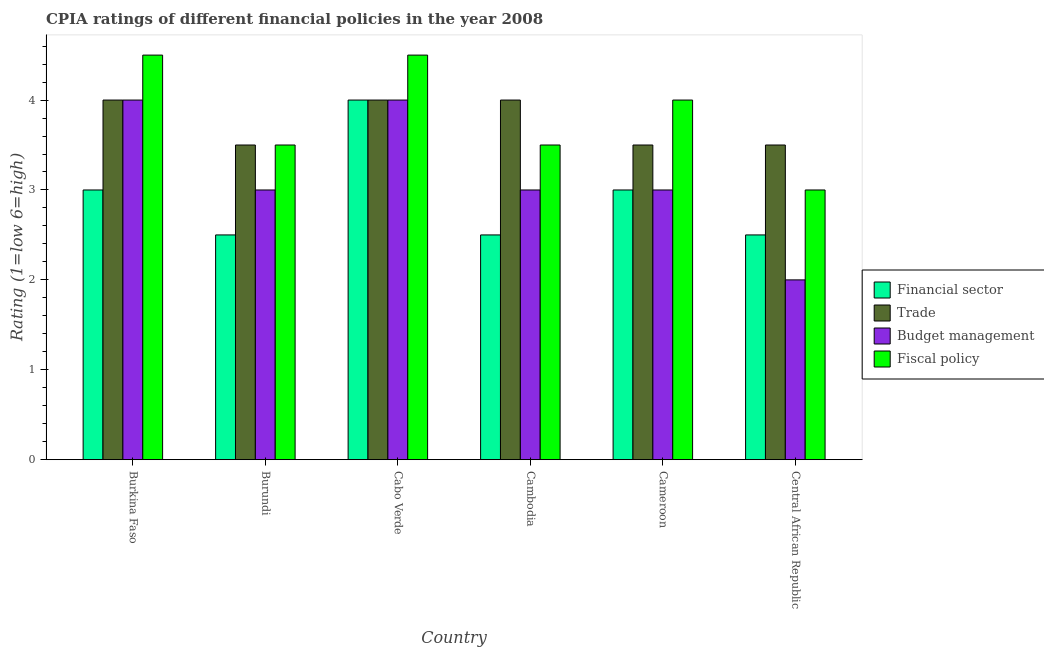How many groups of bars are there?
Provide a succinct answer. 6. Are the number of bars per tick equal to the number of legend labels?
Your response must be concise. Yes. Are the number of bars on each tick of the X-axis equal?
Your response must be concise. Yes. How many bars are there on the 5th tick from the left?
Your answer should be very brief. 4. What is the label of the 4th group of bars from the left?
Keep it short and to the point. Cambodia. What is the cpia rating of fiscal policy in Cambodia?
Your response must be concise. 3.5. Across all countries, what is the maximum cpia rating of fiscal policy?
Offer a very short reply. 4.5. In which country was the cpia rating of fiscal policy maximum?
Provide a short and direct response. Burkina Faso. In which country was the cpia rating of financial sector minimum?
Ensure brevity in your answer.  Burundi. What is the average cpia rating of financial sector per country?
Make the answer very short. 2.92. What is the difference between the cpia rating of financial sector and cpia rating of budget management in Cameroon?
Offer a terse response. 0. What is the ratio of the cpia rating of budget management in Burundi to that in Cameroon?
Make the answer very short. 1. What is the difference between the highest and the second highest cpia rating of financial sector?
Give a very brief answer. 1. What is the difference between the highest and the lowest cpia rating of trade?
Your answer should be compact. 0.5. In how many countries, is the cpia rating of financial sector greater than the average cpia rating of financial sector taken over all countries?
Offer a terse response. 3. Is it the case that in every country, the sum of the cpia rating of trade and cpia rating of budget management is greater than the sum of cpia rating of financial sector and cpia rating of fiscal policy?
Your response must be concise. No. What does the 3rd bar from the left in Central African Republic represents?
Provide a short and direct response. Budget management. What does the 1st bar from the right in Cambodia represents?
Your response must be concise. Fiscal policy. Is it the case that in every country, the sum of the cpia rating of financial sector and cpia rating of trade is greater than the cpia rating of budget management?
Your answer should be compact. Yes. How many bars are there?
Offer a terse response. 24. Are all the bars in the graph horizontal?
Give a very brief answer. No. Are the values on the major ticks of Y-axis written in scientific E-notation?
Offer a terse response. No. Where does the legend appear in the graph?
Give a very brief answer. Center right. How are the legend labels stacked?
Offer a very short reply. Vertical. What is the title of the graph?
Provide a succinct answer. CPIA ratings of different financial policies in the year 2008. Does "Industry" appear as one of the legend labels in the graph?
Give a very brief answer. No. What is the label or title of the X-axis?
Your answer should be very brief. Country. What is the label or title of the Y-axis?
Keep it short and to the point. Rating (1=low 6=high). What is the Rating (1=low 6=high) in Trade in Burkina Faso?
Your response must be concise. 4. What is the Rating (1=low 6=high) of Trade in Burundi?
Provide a short and direct response. 3.5. What is the Rating (1=low 6=high) in Fiscal policy in Burundi?
Keep it short and to the point. 3.5. What is the Rating (1=low 6=high) of Budget management in Cabo Verde?
Provide a succinct answer. 4. What is the Rating (1=low 6=high) in Budget management in Cambodia?
Offer a very short reply. 3. What is the Rating (1=low 6=high) of Financial sector in Cameroon?
Your answer should be compact. 3. What is the Rating (1=low 6=high) in Trade in Cameroon?
Your response must be concise. 3.5. What is the Rating (1=low 6=high) in Budget management in Cameroon?
Offer a terse response. 3. What is the Rating (1=low 6=high) of Fiscal policy in Cameroon?
Your response must be concise. 4. What is the Rating (1=low 6=high) in Fiscal policy in Central African Republic?
Ensure brevity in your answer.  3. Across all countries, what is the maximum Rating (1=low 6=high) of Trade?
Make the answer very short. 4. Across all countries, what is the maximum Rating (1=low 6=high) in Budget management?
Keep it short and to the point. 4. Across all countries, what is the maximum Rating (1=low 6=high) in Fiscal policy?
Keep it short and to the point. 4.5. Across all countries, what is the minimum Rating (1=low 6=high) in Financial sector?
Your answer should be very brief. 2.5. Across all countries, what is the minimum Rating (1=low 6=high) of Fiscal policy?
Offer a terse response. 3. What is the total Rating (1=low 6=high) in Financial sector in the graph?
Make the answer very short. 17.5. What is the total Rating (1=low 6=high) of Trade in the graph?
Your response must be concise. 22.5. What is the total Rating (1=low 6=high) of Budget management in the graph?
Make the answer very short. 19. What is the difference between the Rating (1=low 6=high) of Financial sector in Burkina Faso and that in Burundi?
Provide a short and direct response. 0.5. What is the difference between the Rating (1=low 6=high) in Budget management in Burkina Faso and that in Burundi?
Make the answer very short. 1. What is the difference between the Rating (1=low 6=high) in Financial sector in Burkina Faso and that in Cabo Verde?
Offer a very short reply. -1. What is the difference between the Rating (1=low 6=high) of Budget management in Burkina Faso and that in Cabo Verde?
Provide a succinct answer. 0. What is the difference between the Rating (1=low 6=high) in Financial sector in Burkina Faso and that in Cambodia?
Keep it short and to the point. 0.5. What is the difference between the Rating (1=low 6=high) of Trade in Burkina Faso and that in Cambodia?
Make the answer very short. 0. What is the difference between the Rating (1=low 6=high) of Budget management in Burkina Faso and that in Cambodia?
Your answer should be very brief. 1. What is the difference between the Rating (1=low 6=high) in Financial sector in Burkina Faso and that in Cameroon?
Provide a succinct answer. 0. What is the difference between the Rating (1=low 6=high) of Trade in Burkina Faso and that in Cameroon?
Make the answer very short. 0.5. What is the difference between the Rating (1=low 6=high) of Financial sector in Burundi and that in Cabo Verde?
Provide a short and direct response. -1.5. What is the difference between the Rating (1=low 6=high) of Trade in Burundi and that in Cabo Verde?
Give a very brief answer. -0.5. What is the difference between the Rating (1=low 6=high) in Budget management in Burundi and that in Cambodia?
Your answer should be compact. 0. What is the difference between the Rating (1=low 6=high) of Trade in Burundi and that in Cameroon?
Offer a terse response. 0. What is the difference between the Rating (1=low 6=high) in Budget management in Burundi and that in Cameroon?
Your response must be concise. 0. What is the difference between the Rating (1=low 6=high) of Fiscal policy in Burundi and that in Cameroon?
Offer a very short reply. -0.5. What is the difference between the Rating (1=low 6=high) of Budget management in Burundi and that in Central African Republic?
Offer a very short reply. 1. What is the difference between the Rating (1=low 6=high) in Trade in Cabo Verde and that in Cameroon?
Your response must be concise. 0.5. What is the difference between the Rating (1=low 6=high) in Fiscal policy in Cabo Verde and that in Cameroon?
Your response must be concise. 0.5. What is the difference between the Rating (1=low 6=high) of Trade in Cambodia and that in Cameroon?
Your answer should be very brief. 0.5. What is the difference between the Rating (1=low 6=high) in Budget management in Cambodia and that in Cameroon?
Your answer should be compact. 0. What is the difference between the Rating (1=low 6=high) of Fiscal policy in Cambodia and that in Cameroon?
Give a very brief answer. -0.5. What is the difference between the Rating (1=low 6=high) of Financial sector in Cambodia and that in Central African Republic?
Give a very brief answer. 0. What is the difference between the Rating (1=low 6=high) of Trade in Cambodia and that in Central African Republic?
Provide a succinct answer. 0.5. What is the difference between the Rating (1=low 6=high) in Financial sector in Burkina Faso and the Rating (1=low 6=high) in Budget management in Cabo Verde?
Your answer should be very brief. -1. What is the difference between the Rating (1=low 6=high) in Financial sector in Burkina Faso and the Rating (1=low 6=high) in Fiscal policy in Cabo Verde?
Your answer should be compact. -1.5. What is the difference between the Rating (1=low 6=high) in Budget management in Burkina Faso and the Rating (1=low 6=high) in Fiscal policy in Cabo Verde?
Your answer should be compact. -0.5. What is the difference between the Rating (1=low 6=high) in Financial sector in Burkina Faso and the Rating (1=low 6=high) in Trade in Cambodia?
Make the answer very short. -1. What is the difference between the Rating (1=low 6=high) of Financial sector in Burkina Faso and the Rating (1=low 6=high) of Budget management in Cambodia?
Your answer should be compact. 0. What is the difference between the Rating (1=low 6=high) in Budget management in Burkina Faso and the Rating (1=low 6=high) in Fiscal policy in Cambodia?
Ensure brevity in your answer.  0.5. What is the difference between the Rating (1=low 6=high) of Financial sector in Burkina Faso and the Rating (1=low 6=high) of Trade in Cameroon?
Give a very brief answer. -0.5. What is the difference between the Rating (1=low 6=high) in Financial sector in Burkina Faso and the Rating (1=low 6=high) in Fiscal policy in Cameroon?
Offer a terse response. -1. What is the difference between the Rating (1=low 6=high) in Trade in Burkina Faso and the Rating (1=low 6=high) in Budget management in Cameroon?
Your answer should be very brief. 1. What is the difference between the Rating (1=low 6=high) of Financial sector in Burkina Faso and the Rating (1=low 6=high) of Trade in Central African Republic?
Make the answer very short. -0.5. What is the difference between the Rating (1=low 6=high) in Financial sector in Burkina Faso and the Rating (1=low 6=high) in Budget management in Central African Republic?
Offer a very short reply. 1. What is the difference between the Rating (1=low 6=high) of Trade in Burkina Faso and the Rating (1=low 6=high) of Budget management in Central African Republic?
Keep it short and to the point. 2. What is the difference between the Rating (1=low 6=high) in Financial sector in Burundi and the Rating (1=low 6=high) in Budget management in Cabo Verde?
Ensure brevity in your answer.  -1.5. What is the difference between the Rating (1=low 6=high) in Financial sector in Burundi and the Rating (1=low 6=high) in Fiscal policy in Cabo Verde?
Offer a very short reply. -2. What is the difference between the Rating (1=low 6=high) of Budget management in Burundi and the Rating (1=low 6=high) of Fiscal policy in Cabo Verde?
Make the answer very short. -1.5. What is the difference between the Rating (1=low 6=high) of Financial sector in Burundi and the Rating (1=low 6=high) of Trade in Cambodia?
Your response must be concise. -1.5. What is the difference between the Rating (1=low 6=high) in Financial sector in Burundi and the Rating (1=low 6=high) in Fiscal policy in Cambodia?
Your response must be concise. -1. What is the difference between the Rating (1=low 6=high) of Budget management in Burundi and the Rating (1=low 6=high) of Fiscal policy in Cambodia?
Your answer should be compact. -0.5. What is the difference between the Rating (1=low 6=high) in Financial sector in Burundi and the Rating (1=low 6=high) in Trade in Cameroon?
Make the answer very short. -1. What is the difference between the Rating (1=low 6=high) in Financial sector in Burundi and the Rating (1=low 6=high) in Fiscal policy in Cameroon?
Ensure brevity in your answer.  -1.5. What is the difference between the Rating (1=low 6=high) in Trade in Burundi and the Rating (1=low 6=high) in Budget management in Cameroon?
Offer a very short reply. 0.5. What is the difference between the Rating (1=low 6=high) in Financial sector in Burundi and the Rating (1=low 6=high) in Budget management in Central African Republic?
Give a very brief answer. 0.5. What is the difference between the Rating (1=low 6=high) in Financial sector in Burundi and the Rating (1=low 6=high) in Fiscal policy in Central African Republic?
Give a very brief answer. -0.5. What is the difference between the Rating (1=low 6=high) of Trade in Burundi and the Rating (1=low 6=high) of Budget management in Central African Republic?
Offer a very short reply. 1.5. What is the difference between the Rating (1=low 6=high) in Budget management in Burundi and the Rating (1=low 6=high) in Fiscal policy in Central African Republic?
Your response must be concise. 0. What is the difference between the Rating (1=low 6=high) of Financial sector in Cabo Verde and the Rating (1=low 6=high) of Trade in Cambodia?
Ensure brevity in your answer.  0. What is the difference between the Rating (1=low 6=high) in Trade in Cabo Verde and the Rating (1=low 6=high) in Fiscal policy in Cambodia?
Your answer should be very brief. 0.5. What is the difference between the Rating (1=low 6=high) of Budget management in Cabo Verde and the Rating (1=low 6=high) of Fiscal policy in Cambodia?
Your response must be concise. 0.5. What is the difference between the Rating (1=low 6=high) in Financial sector in Cabo Verde and the Rating (1=low 6=high) in Fiscal policy in Cameroon?
Provide a succinct answer. 0. What is the difference between the Rating (1=low 6=high) of Budget management in Cabo Verde and the Rating (1=low 6=high) of Fiscal policy in Cameroon?
Offer a terse response. 0. What is the difference between the Rating (1=low 6=high) in Financial sector in Cabo Verde and the Rating (1=low 6=high) in Trade in Central African Republic?
Make the answer very short. 0.5. What is the difference between the Rating (1=low 6=high) of Budget management in Cabo Verde and the Rating (1=low 6=high) of Fiscal policy in Central African Republic?
Offer a very short reply. 1. What is the difference between the Rating (1=low 6=high) of Financial sector in Cambodia and the Rating (1=low 6=high) of Budget management in Cameroon?
Offer a very short reply. -0.5. What is the difference between the Rating (1=low 6=high) in Financial sector in Cambodia and the Rating (1=low 6=high) in Fiscal policy in Cameroon?
Offer a very short reply. -1.5. What is the difference between the Rating (1=low 6=high) of Trade in Cambodia and the Rating (1=low 6=high) of Fiscal policy in Cameroon?
Give a very brief answer. 0. What is the difference between the Rating (1=low 6=high) in Financial sector in Cambodia and the Rating (1=low 6=high) in Budget management in Central African Republic?
Provide a short and direct response. 0.5. What is the difference between the Rating (1=low 6=high) in Financial sector in Cambodia and the Rating (1=low 6=high) in Fiscal policy in Central African Republic?
Offer a very short reply. -0.5. What is the difference between the Rating (1=low 6=high) of Trade in Cambodia and the Rating (1=low 6=high) of Budget management in Central African Republic?
Keep it short and to the point. 2. What is the difference between the Rating (1=low 6=high) of Budget management in Cambodia and the Rating (1=low 6=high) of Fiscal policy in Central African Republic?
Your answer should be very brief. 0. What is the difference between the Rating (1=low 6=high) of Financial sector in Cameroon and the Rating (1=low 6=high) of Trade in Central African Republic?
Provide a succinct answer. -0.5. What is the difference between the Rating (1=low 6=high) of Financial sector in Cameroon and the Rating (1=low 6=high) of Budget management in Central African Republic?
Make the answer very short. 1. What is the difference between the Rating (1=low 6=high) in Trade in Cameroon and the Rating (1=low 6=high) in Fiscal policy in Central African Republic?
Provide a succinct answer. 0.5. What is the difference between the Rating (1=low 6=high) of Budget management in Cameroon and the Rating (1=low 6=high) of Fiscal policy in Central African Republic?
Keep it short and to the point. 0. What is the average Rating (1=low 6=high) of Financial sector per country?
Your answer should be compact. 2.92. What is the average Rating (1=low 6=high) of Trade per country?
Keep it short and to the point. 3.75. What is the average Rating (1=low 6=high) of Budget management per country?
Keep it short and to the point. 3.17. What is the average Rating (1=low 6=high) in Fiscal policy per country?
Provide a short and direct response. 3.83. What is the difference between the Rating (1=low 6=high) of Financial sector and Rating (1=low 6=high) of Trade in Burkina Faso?
Offer a very short reply. -1. What is the difference between the Rating (1=low 6=high) in Financial sector and Rating (1=low 6=high) in Budget management in Burkina Faso?
Give a very brief answer. -1. What is the difference between the Rating (1=low 6=high) in Financial sector and Rating (1=low 6=high) in Fiscal policy in Burkina Faso?
Provide a succinct answer. -1.5. What is the difference between the Rating (1=low 6=high) of Trade and Rating (1=low 6=high) of Fiscal policy in Burkina Faso?
Your answer should be compact. -0.5. What is the difference between the Rating (1=low 6=high) in Trade and Rating (1=low 6=high) in Budget management in Burundi?
Keep it short and to the point. 0.5. What is the difference between the Rating (1=low 6=high) of Financial sector and Rating (1=low 6=high) of Trade in Cabo Verde?
Your answer should be very brief. 0. What is the difference between the Rating (1=low 6=high) of Financial sector and Rating (1=low 6=high) of Budget management in Cabo Verde?
Your response must be concise. 0. What is the difference between the Rating (1=low 6=high) in Budget management and Rating (1=low 6=high) in Fiscal policy in Cabo Verde?
Offer a very short reply. -0.5. What is the difference between the Rating (1=low 6=high) of Financial sector and Rating (1=low 6=high) of Fiscal policy in Cambodia?
Offer a very short reply. -1. What is the difference between the Rating (1=low 6=high) in Trade and Rating (1=low 6=high) in Budget management in Cambodia?
Your response must be concise. 1. What is the difference between the Rating (1=low 6=high) of Trade and Rating (1=low 6=high) of Fiscal policy in Cambodia?
Give a very brief answer. 0.5. What is the difference between the Rating (1=low 6=high) of Financial sector and Rating (1=low 6=high) of Trade in Cameroon?
Make the answer very short. -0.5. What is the difference between the Rating (1=low 6=high) in Trade and Rating (1=low 6=high) in Budget management in Cameroon?
Give a very brief answer. 0.5. What is the difference between the Rating (1=low 6=high) in Trade and Rating (1=low 6=high) in Fiscal policy in Cameroon?
Keep it short and to the point. -0.5. What is the difference between the Rating (1=low 6=high) in Financial sector and Rating (1=low 6=high) in Trade in Central African Republic?
Your response must be concise. -1. What is the difference between the Rating (1=low 6=high) of Financial sector and Rating (1=low 6=high) of Fiscal policy in Central African Republic?
Ensure brevity in your answer.  -0.5. What is the difference between the Rating (1=low 6=high) of Trade and Rating (1=low 6=high) of Budget management in Central African Republic?
Offer a very short reply. 1.5. What is the difference between the Rating (1=low 6=high) in Trade and Rating (1=low 6=high) in Fiscal policy in Central African Republic?
Offer a very short reply. 0.5. What is the ratio of the Rating (1=low 6=high) in Financial sector in Burkina Faso to that in Burundi?
Offer a terse response. 1.2. What is the ratio of the Rating (1=low 6=high) of Trade in Burkina Faso to that in Burundi?
Give a very brief answer. 1.14. What is the ratio of the Rating (1=low 6=high) in Financial sector in Burkina Faso to that in Cabo Verde?
Offer a terse response. 0.75. What is the ratio of the Rating (1=low 6=high) of Budget management in Burkina Faso to that in Cabo Verde?
Provide a succinct answer. 1. What is the ratio of the Rating (1=low 6=high) in Financial sector in Burkina Faso to that in Cambodia?
Your answer should be very brief. 1.2. What is the ratio of the Rating (1=low 6=high) in Budget management in Burkina Faso to that in Cambodia?
Your answer should be very brief. 1.33. What is the ratio of the Rating (1=low 6=high) in Trade in Burkina Faso to that in Cameroon?
Offer a terse response. 1.14. What is the ratio of the Rating (1=low 6=high) of Fiscal policy in Burkina Faso to that in Central African Republic?
Offer a terse response. 1.5. What is the ratio of the Rating (1=low 6=high) of Financial sector in Burundi to that in Cabo Verde?
Provide a succinct answer. 0.62. What is the ratio of the Rating (1=low 6=high) in Trade in Burundi to that in Cabo Verde?
Offer a very short reply. 0.88. What is the ratio of the Rating (1=low 6=high) in Budget management in Burundi to that in Cabo Verde?
Provide a succinct answer. 0.75. What is the ratio of the Rating (1=low 6=high) of Fiscal policy in Burundi to that in Cabo Verde?
Offer a terse response. 0.78. What is the ratio of the Rating (1=low 6=high) of Trade in Burundi to that in Cambodia?
Offer a very short reply. 0.88. What is the ratio of the Rating (1=low 6=high) of Budget management in Burundi to that in Cambodia?
Provide a short and direct response. 1. What is the ratio of the Rating (1=low 6=high) of Fiscal policy in Burundi to that in Cambodia?
Offer a very short reply. 1. What is the ratio of the Rating (1=low 6=high) of Fiscal policy in Burundi to that in Cameroon?
Give a very brief answer. 0.88. What is the ratio of the Rating (1=low 6=high) of Budget management in Burundi to that in Central African Republic?
Offer a very short reply. 1.5. What is the ratio of the Rating (1=low 6=high) in Trade in Cabo Verde to that in Cambodia?
Offer a very short reply. 1. What is the ratio of the Rating (1=low 6=high) in Budget management in Cabo Verde to that in Cambodia?
Your answer should be compact. 1.33. What is the ratio of the Rating (1=low 6=high) in Financial sector in Cabo Verde to that in Cameroon?
Provide a short and direct response. 1.33. What is the ratio of the Rating (1=low 6=high) in Budget management in Cabo Verde to that in Cameroon?
Make the answer very short. 1.33. What is the ratio of the Rating (1=low 6=high) of Fiscal policy in Cabo Verde to that in Cameroon?
Keep it short and to the point. 1.12. What is the ratio of the Rating (1=low 6=high) of Financial sector in Cabo Verde to that in Central African Republic?
Ensure brevity in your answer.  1.6. What is the ratio of the Rating (1=low 6=high) in Trade in Cabo Verde to that in Central African Republic?
Ensure brevity in your answer.  1.14. What is the ratio of the Rating (1=low 6=high) of Budget management in Cabo Verde to that in Central African Republic?
Offer a very short reply. 2. What is the ratio of the Rating (1=low 6=high) in Fiscal policy in Cabo Verde to that in Central African Republic?
Give a very brief answer. 1.5. What is the ratio of the Rating (1=low 6=high) of Budget management in Cambodia to that in Cameroon?
Make the answer very short. 1. What is the ratio of the Rating (1=low 6=high) of Fiscal policy in Cambodia to that in Cameroon?
Give a very brief answer. 0.88. What is the ratio of the Rating (1=low 6=high) in Financial sector in Cameroon to that in Central African Republic?
Offer a very short reply. 1.2. What is the ratio of the Rating (1=low 6=high) in Trade in Cameroon to that in Central African Republic?
Offer a terse response. 1. What is the ratio of the Rating (1=low 6=high) of Budget management in Cameroon to that in Central African Republic?
Provide a succinct answer. 1.5. What is the difference between the highest and the second highest Rating (1=low 6=high) of Trade?
Your answer should be very brief. 0. What is the difference between the highest and the second highest Rating (1=low 6=high) in Budget management?
Your answer should be compact. 0. What is the difference between the highest and the lowest Rating (1=low 6=high) of Financial sector?
Give a very brief answer. 1.5. What is the difference between the highest and the lowest Rating (1=low 6=high) in Trade?
Keep it short and to the point. 0.5. What is the difference between the highest and the lowest Rating (1=low 6=high) of Budget management?
Provide a succinct answer. 2. 